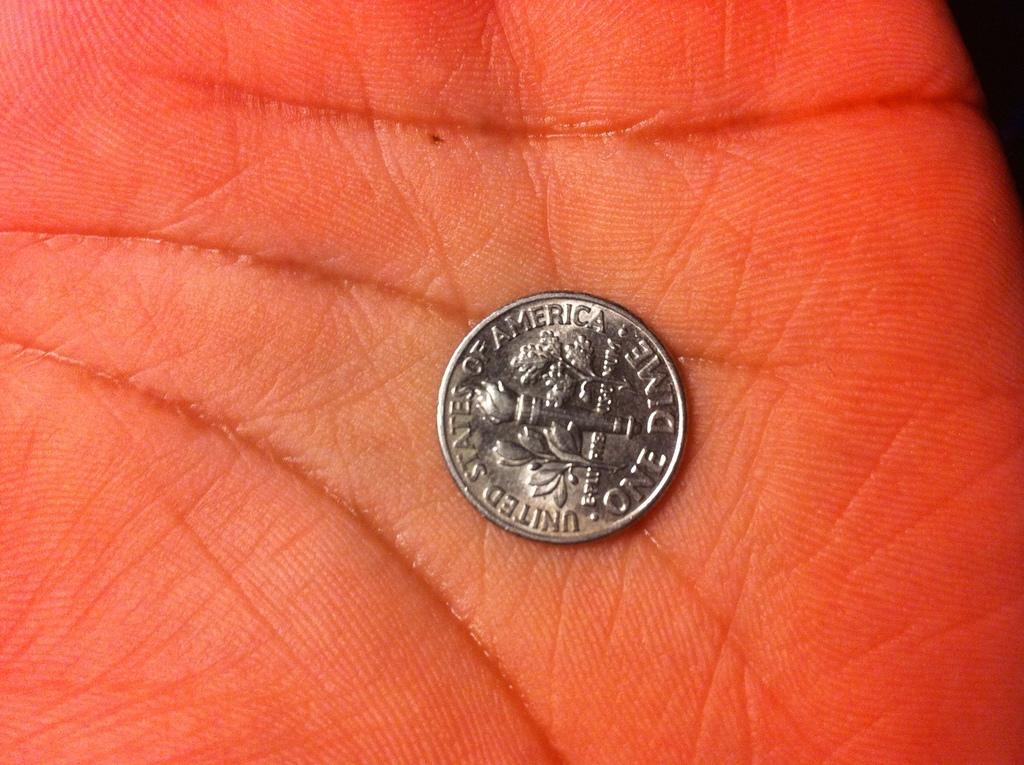What object is the main focus of the image? There is a coin in the image. Where is the coin located? The coin is on a palm. What type of sweater is the person wearing in the image? There is no person or sweater present in the image; it only features a coin on a palm. 